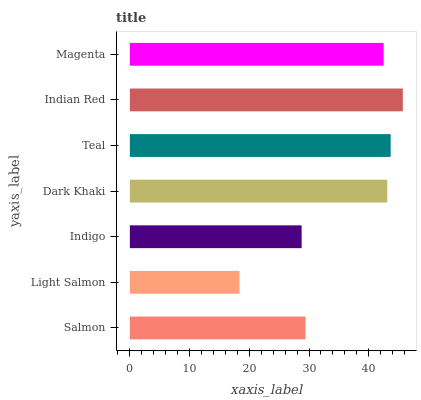Is Light Salmon the minimum?
Answer yes or no. Yes. Is Indian Red the maximum?
Answer yes or no. Yes. Is Indigo the minimum?
Answer yes or no. No. Is Indigo the maximum?
Answer yes or no. No. Is Indigo greater than Light Salmon?
Answer yes or no. Yes. Is Light Salmon less than Indigo?
Answer yes or no. Yes. Is Light Salmon greater than Indigo?
Answer yes or no. No. Is Indigo less than Light Salmon?
Answer yes or no. No. Is Magenta the high median?
Answer yes or no. Yes. Is Magenta the low median?
Answer yes or no. Yes. Is Dark Khaki the high median?
Answer yes or no. No. Is Dark Khaki the low median?
Answer yes or no. No. 